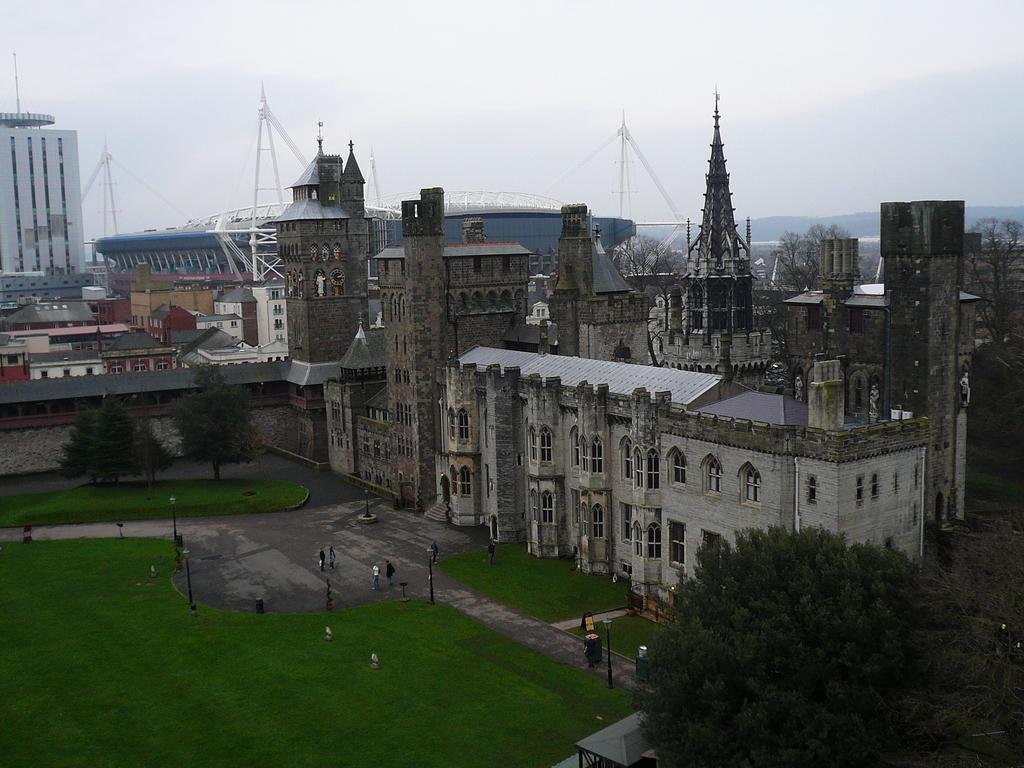What type of structures can be seen in the image? There are buildings in the image. What type of vegetation is present in the image? There are trees and grass visible in the image. What are the poles on the ground used for in the image? The purpose of the poles on the ground is not specified in the image. What can be seen in the background of the image? The sky is visible in the background of the image. What type of beef is being served at the restaurant in the image? There is no restaurant or beef present in the image. Does the existence of the buildings in the image prove the existence of extraterrestrial life? The presence of buildings in the image does not provide any information about the existence of extraterrestrial life. 